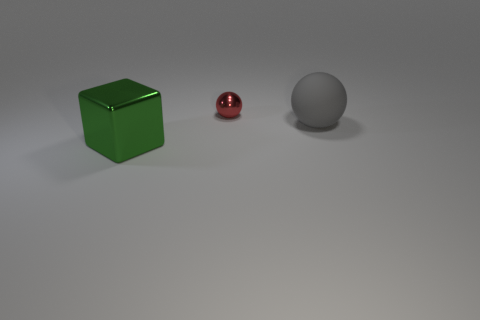Is the number of metallic cubes less than the number of large yellow metallic cylinders?
Offer a very short reply. No. What number of other things are there of the same color as the tiny sphere?
Keep it short and to the point. 0. How many large gray matte balls are there?
Ensure brevity in your answer.  1. Are there fewer small red spheres behind the tiny sphere than purple metal cylinders?
Your answer should be very brief. No. Does the big object in front of the big gray thing have the same material as the big ball?
Provide a succinct answer. No. What is the shape of the large thing that is to the left of the object that is behind the big object to the right of the red sphere?
Ensure brevity in your answer.  Cube. Is there a cyan metal ball of the same size as the shiny cube?
Your answer should be compact. No. How big is the gray object?
Ensure brevity in your answer.  Large. How many blue things are the same size as the gray object?
Offer a very short reply. 0. Are there fewer big gray matte spheres that are behind the tiny red shiny sphere than green blocks to the left of the gray object?
Make the answer very short. Yes. 